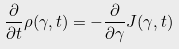Convert formula to latex. <formula><loc_0><loc_0><loc_500><loc_500>\frac { \partial } { \partial t } \rho ( \gamma , t ) = - \frac { \partial } { \partial \gamma } J ( \gamma , t )</formula> 